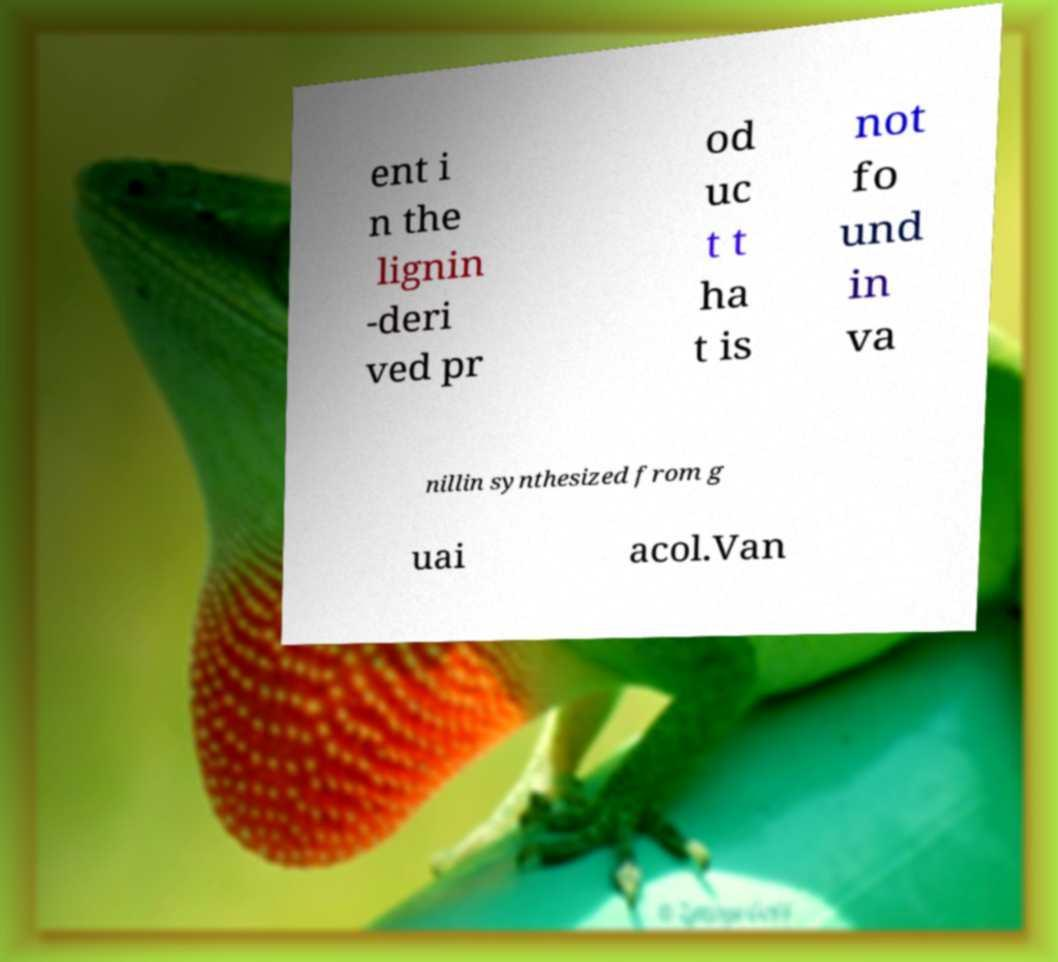Could you assist in decoding the text presented in this image and type it out clearly? ent i n the lignin -deri ved pr od uc t t ha t is not fo und in va nillin synthesized from g uai acol.Van 